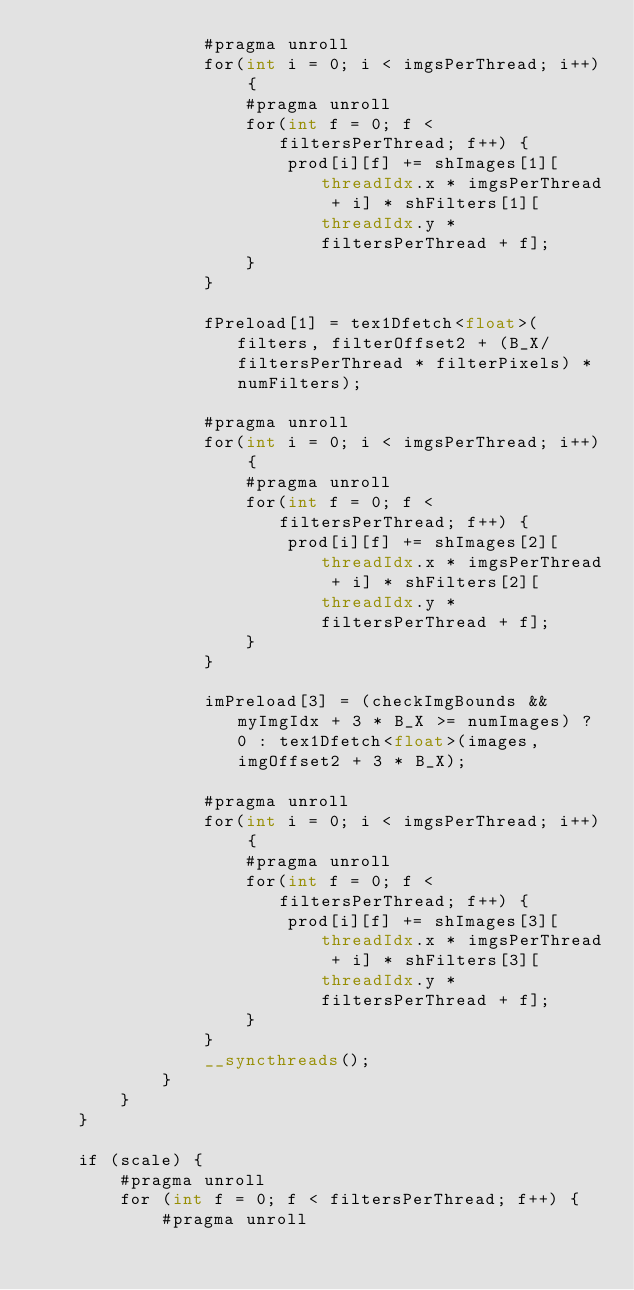<code> <loc_0><loc_0><loc_500><loc_500><_Cuda_>                #pragma unroll
                for(int i = 0; i < imgsPerThread; i++) {
                    #pragma unroll
                    for(int f = 0; f < filtersPerThread; f++) {
                        prod[i][f] += shImages[1][threadIdx.x * imgsPerThread + i] * shFilters[1][threadIdx.y * filtersPerThread + f];
                    }
                }

                fPreload[1] = tex1Dfetch<float>(filters, filterOffset2 + (B_X/filtersPerThread * filterPixels) * numFilters);

                #pragma unroll
                for(int i = 0; i < imgsPerThread; i++) {
                    #pragma unroll
                    for(int f = 0; f < filtersPerThread; f++) {
                        prod[i][f] += shImages[2][threadIdx.x * imgsPerThread + i] * shFilters[2][threadIdx.y * filtersPerThread + f];
                    }
                }

                imPreload[3] = (checkImgBounds && myImgIdx + 3 * B_X >= numImages) ? 0 : tex1Dfetch<float>(images, imgOffset2 + 3 * B_X);

                #pragma unroll
                for(int i = 0; i < imgsPerThread; i++) {
                    #pragma unroll
                    for(int f = 0; f < filtersPerThread; f++) {
                        prod[i][f] += shImages[3][threadIdx.x * imgsPerThread + i] * shFilters[3][threadIdx.y * filtersPerThread + f];
                    }
                }
                __syncthreads();
            }
        }
    }

    if (scale) {
        #pragma unroll
        for (int f = 0; f < filtersPerThread; f++) {
            #pragma unroll</code> 